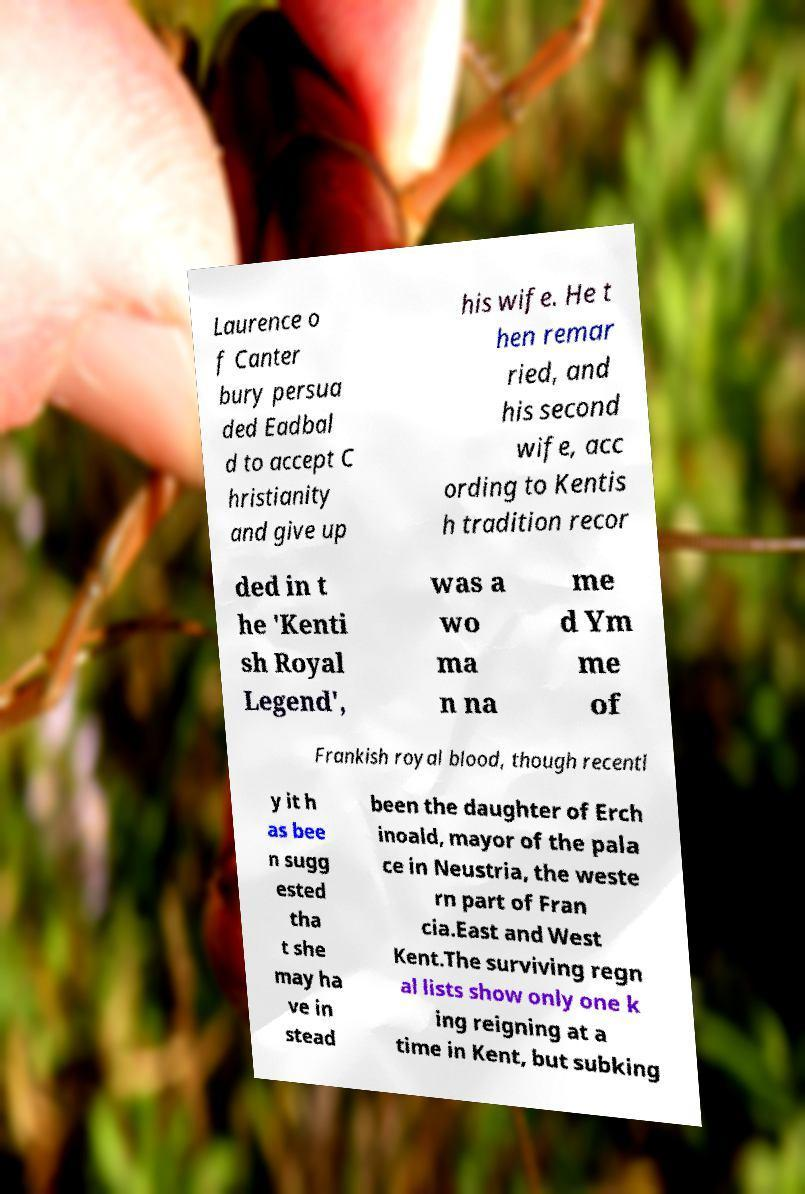Can you accurately transcribe the text from the provided image for me? Laurence o f Canter bury persua ded Eadbal d to accept C hristianity and give up his wife. He t hen remar ried, and his second wife, acc ording to Kentis h tradition recor ded in t he 'Kenti sh Royal Legend', was a wo ma n na me d Ym me of Frankish royal blood, though recentl y it h as bee n sugg ested tha t she may ha ve in stead been the daughter of Erch inoald, mayor of the pala ce in Neustria, the weste rn part of Fran cia.East and West Kent.The surviving regn al lists show only one k ing reigning at a time in Kent, but subking 